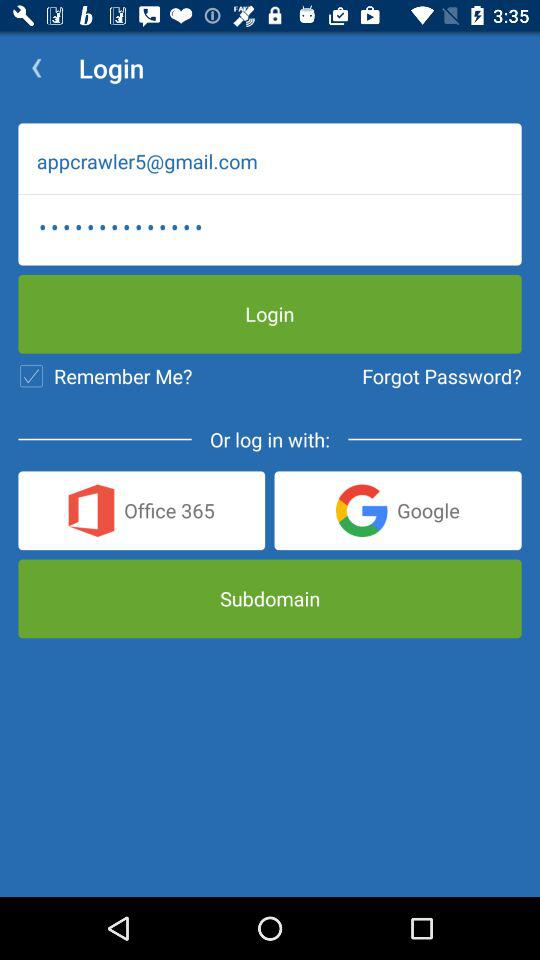Which application can the user log in with? The user can log in with "Office 356" and "Google". 